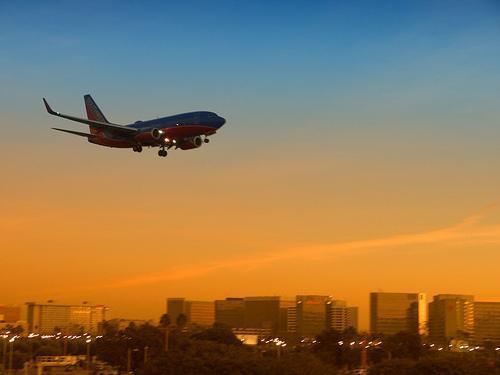How many planes are there?
Give a very brief answer. 1. 